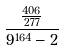<formula> <loc_0><loc_0><loc_500><loc_500>\frac { \frac { 4 0 6 } { 2 7 7 } } { 9 ^ { 1 6 4 } - 2 }</formula> 